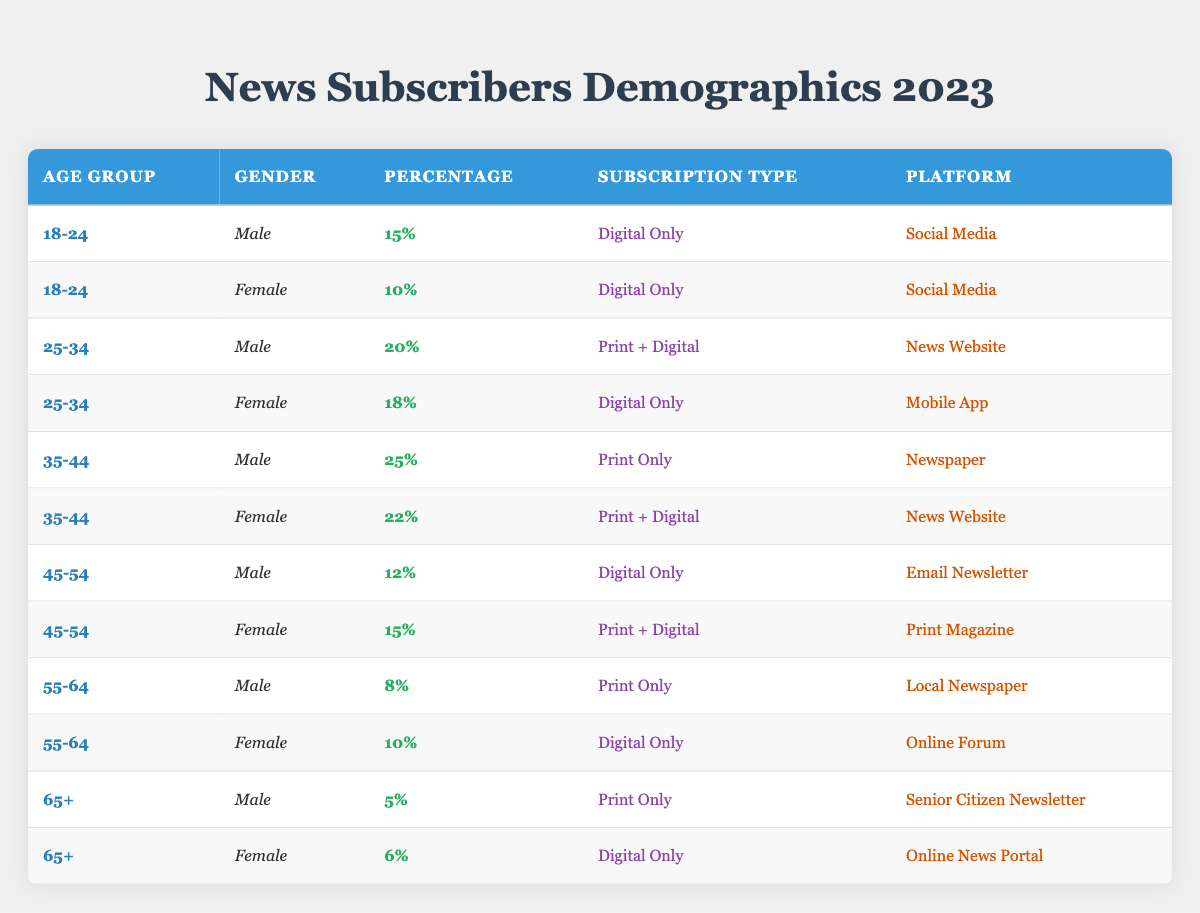What percentage of male subscribers are aged 35-44? From the table, the percentage of male subscribers in the age group 35-44 is listed as 25%.
Answer: 25% What is the most common subscription type for females aged 25-34? The table shows that females aged 25-34 have the largest percentage (18%) under the subscription type "Digital Only".
Answer: Digital Only How many females are there in the age group 45-54 with a subscription type of Print + Digital? In the table, the age group 45-54 for females shows a percentage of 15% for the subscription type Print + Digital.
Answer: 15% Does any age group have more male subscribers than female subscribers for the Digital Only subscription type? Referring to the table, in the age group 18-24, male subscribers (15%) outnumber female subscribers (10%) for Digital Only, confirming that at least one age group favors male subscribers significantly.
Answer: Yes What is the combined percentage of male and female subscribers aged 55-64 with a Print Only subscription? For males aged 55-64, the percentage is 8%, while for females it is not applicable. Therefore, the combined percentage for Print Only in this age group is only 8%.
Answer: 8% What age group has the highest percentage of subscribers for the Print + Digital subscription? The 35-44 age group has 22% of females and 25% of males, summing to a total of 47%. This is higher than other age groups’ percentages for Print + Digital.
Answer: 35-44 What is the percentage difference in Digital Only subscriptions between males and females aged 45-54? The percentage for males aged 45-54 is 12%, while for females it is 15%. The difference is 15% - 12%, equating to a 3% higher percentage for females.
Answer: 3% How many total subscribers are aged 18-24? The subscribers aged 18-24 count 15% males and 10% females, totaling 25% for this age group.
Answer: 25% Which platform has the highest percentage of female subscribers for the age group 35-44? The table indicates that the News Website platform has 22% for female subscribers aged 35-44, which is the highest among the listed percentages for that age group.
Answer: News Website 